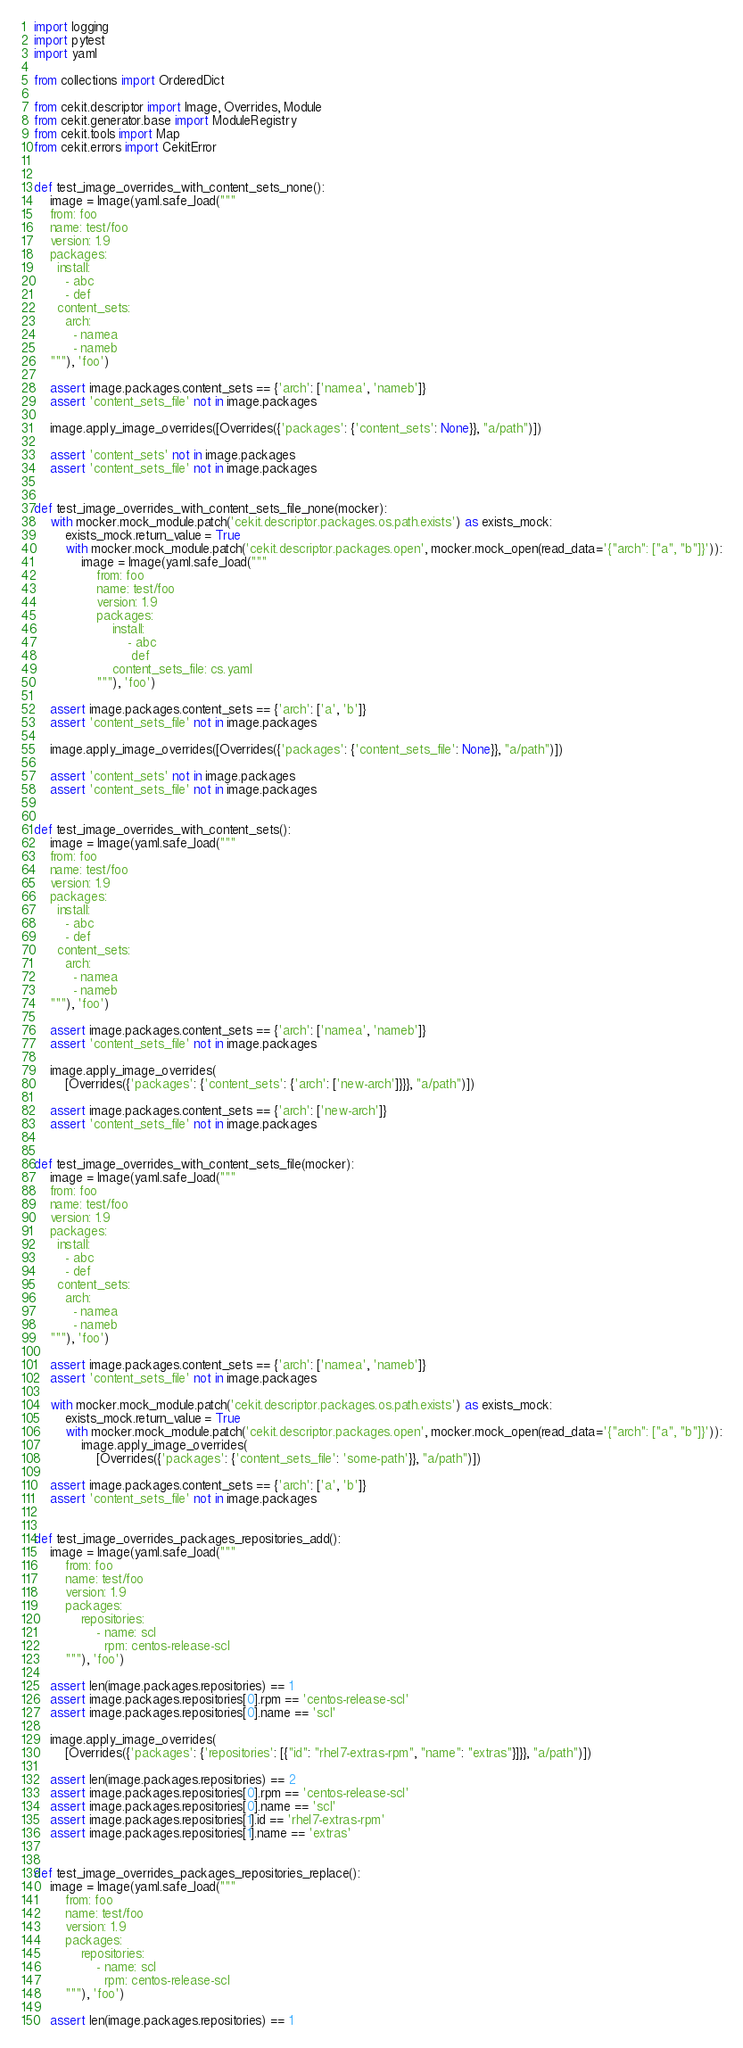<code> <loc_0><loc_0><loc_500><loc_500><_Python_>import logging
import pytest
import yaml

from collections import OrderedDict

from cekit.descriptor import Image, Overrides, Module
from cekit.generator.base import ModuleRegistry
from cekit.tools import Map
from cekit.errors import CekitError


def test_image_overrides_with_content_sets_none():
    image = Image(yaml.safe_load("""
    from: foo
    name: test/foo
    version: 1.9
    packages:
      install:
        - abc
        - def
      content_sets:
        arch:
          - namea
          - nameb
    """), 'foo')

    assert image.packages.content_sets == {'arch': ['namea', 'nameb']}
    assert 'content_sets_file' not in image.packages

    image.apply_image_overrides([Overrides({'packages': {'content_sets': None}}, "a/path")])

    assert 'content_sets' not in image.packages
    assert 'content_sets_file' not in image.packages


def test_image_overrides_with_content_sets_file_none(mocker):
    with mocker.mock_module.patch('cekit.descriptor.packages.os.path.exists') as exists_mock:
        exists_mock.return_value = True
        with mocker.mock_module.patch('cekit.descriptor.packages.open', mocker.mock_open(read_data='{"arch": ["a", "b"]}')):
            image = Image(yaml.safe_load("""
                from: foo
                name: test/foo
                version: 1.9
                packages:
                    install:
                        - abc
                         def
                    content_sets_file: cs.yaml
                """), 'foo')

    assert image.packages.content_sets == {'arch': ['a', 'b']}
    assert 'content_sets_file' not in image.packages

    image.apply_image_overrides([Overrides({'packages': {'content_sets_file': None}}, "a/path")])

    assert 'content_sets' not in image.packages
    assert 'content_sets_file' not in image.packages


def test_image_overrides_with_content_sets():
    image = Image(yaml.safe_load("""
    from: foo
    name: test/foo
    version: 1.9
    packages:
      install:
        - abc
        - def
      content_sets:
        arch:
          - namea
          - nameb
    """), 'foo')

    assert image.packages.content_sets == {'arch': ['namea', 'nameb']}
    assert 'content_sets_file' not in image.packages

    image.apply_image_overrides(
        [Overrides({'packages': {'content_sets': {'arch': ['new-arch']}}}, "a/path")])

    assert image.packages.content_sets == {'arch': ['new-arch']}
    assert 'content_sets_file' not in image.packages


def test_image_overrides_with_content_sets_file(mocker):
    image = Image(yaml.safe_load("""
    from: foo
    name: test/foo
    version: 1.9
    packages:
      install:
        - abc
        - def
      content_sets:
        arch:
          - namea
          - nameb
    """), 'foo')

    assert image.packages.content_sets == {'arch': ['namea', 'nameb']}
    assert 'content_sets_file' not in image.packages

    with mocker.mock_module.patch('cekit.descriptor.packages.os.path.exists') as exists_mock:
        exists_mock.return_value = True
        with mocker.mock_module.patch('cekit.descriptor.packages.open', mocker.mock_open(read_data='{"arch": ["a", "b"]}')):
            image.apply_image_overrides(
                [Overrides({'packages': {'content_sets_file': 'some-path'}}, "a/path")])

    assert image.packages.content_sets == {'arch': ['a', 'b']}
    assert 'content_sets_file' not in image.packages


def test_image_overrides_packages_repositories_add():
    image = Image(yaml.safe_load("""
        from: foo
        name: test/foo
        version: 1.9
        packages:
            repositories:
                - name: scl
                  rpm: centos-release-scl
        """), 'foo')

    assert len(image.packages.repositories) == 1
    assert image.packages.repositories[0].rpm == 'centos-release-scl'
    assert image.packages.repositories[0].name == 'scl'

    image.apply_image_overrides(
        [Overrides({'packages': {'repositories': [{"id": "rhel7-extras-rpm", "name": "extras"}]}}, "a/path")])

    assert len(image.packages.repositories) == 2
    assert image.packages.repositories[0].rpm == 'centos-release-scl'
    assert image.packages.repositories[0].name == 'scl'
    assert image.packages.repositories[1].id == 'rhel7-extras-rpm'
    assert image.packages.repositories[1].name == 'extras'


def test_image_overrides_packages_repositories_replace():
    image = Image(yaml.safe_load("""
        from: foo
        name: test/foo
        version: 1.9
        packages:
            repositories:
                - name: scl
                  rpm: centos-release-scl
        """), 'foo')

    assert len(image.packages.repositories) == 1</code> 